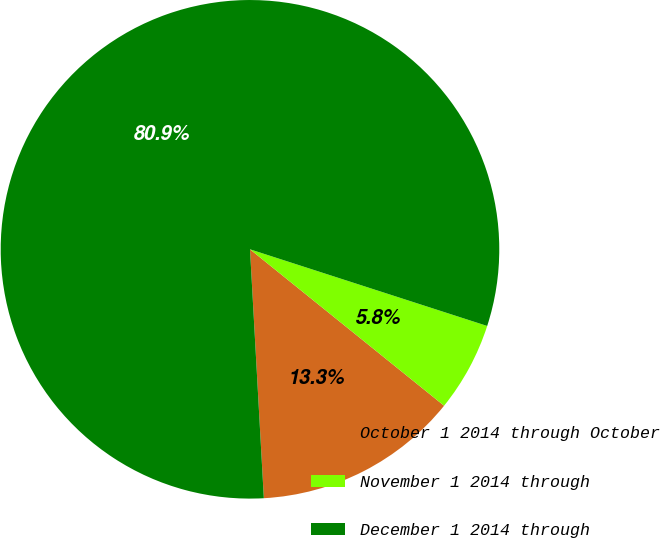Convert chart to OTSL. <chart><loc_0><loc_0><loc_500><loc_500><pie_chart><fcel>October 1 2014 through October<fcel>November 1 2014 through<fcel>December 1 2014 through<nl><fcel>13.32%<fcel>5.82%<fcel>80.86%<nl></chart> 